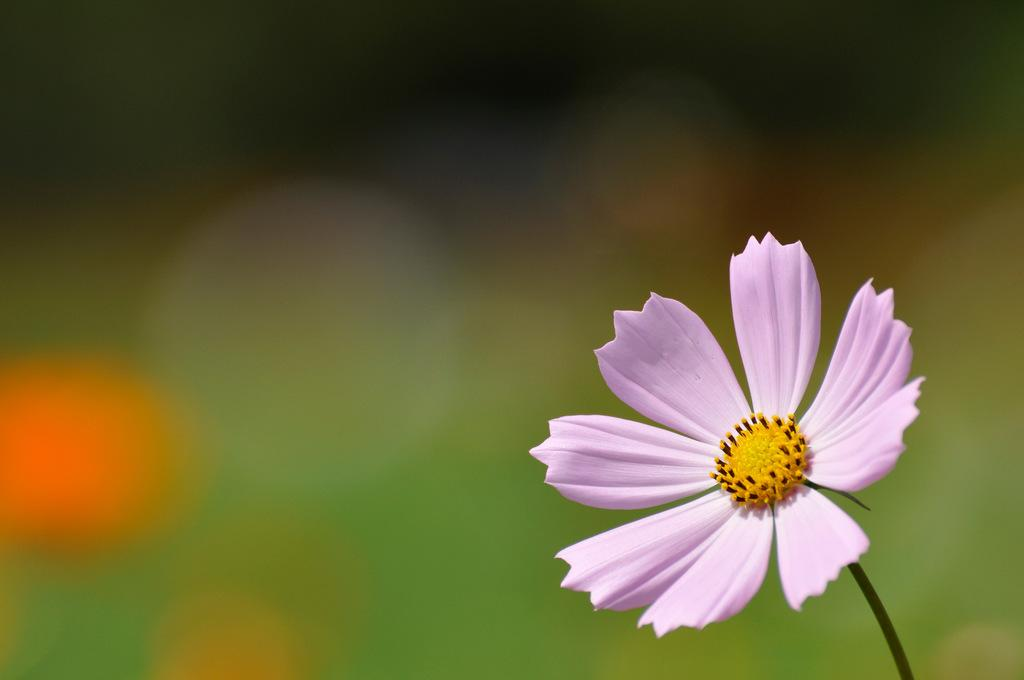What is the main subject of the image? There is a flower in the image. Can you describe the flower in more detail? The flower has a stem. What can be observed about the background of the image? The background of the image is blurry. What type of bag is hanging from the flower's stem in the image? There is no bag present in the image; it features a flower with a stem and a blurry background. 